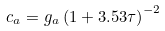<formula> <loc_0><loc_0><loc_500><loc_500>c _ { a } = g _ { a } \left ( 1 + 3 . 5 3 \tau \right ) ^ { - 2 }</formula> 